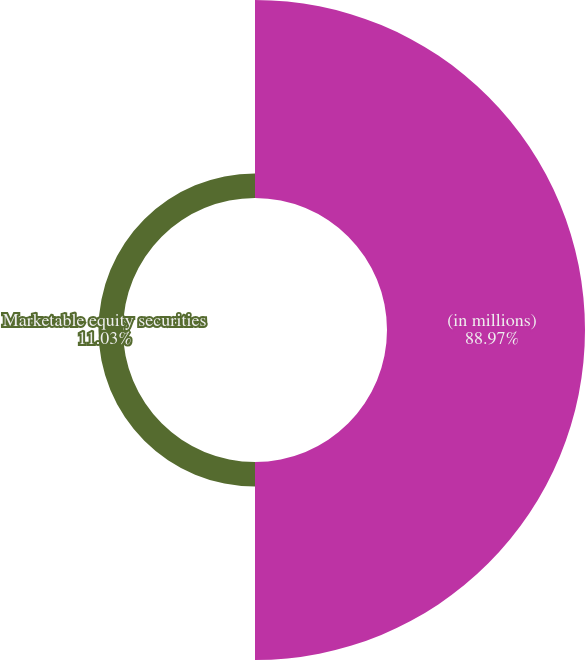<chart> <loc_0><loc_0><loc_500><loc_500><pie_chart><fcel>(in millions)<fcel>Marketable equity securities<nl><fcel>88.97%<fcel>11.03%<nl></chart> 